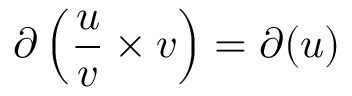Convert formula to latex. <formula><loc_0><loc_0><loc_500><loc_500>\partial \left ( { \frac { u } { v } } \times v \right ) = \partial ( u )</formula> 